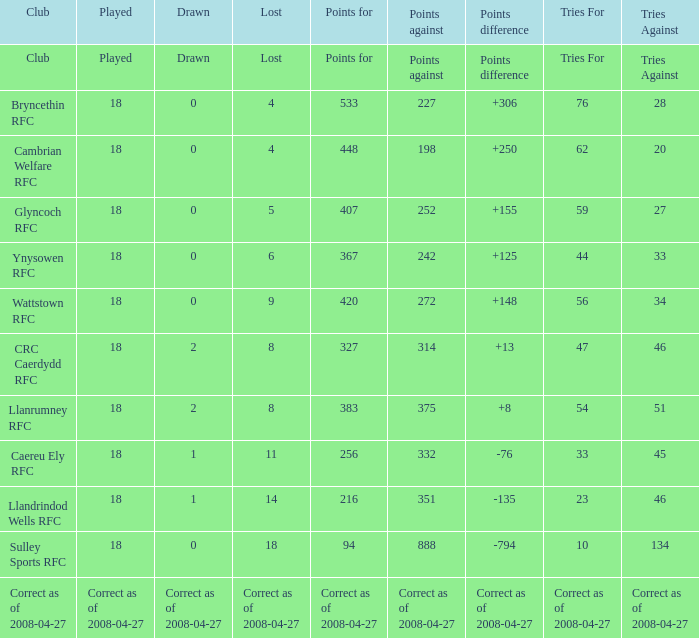What is the significance of the item "points" when the value of the item "points against" is 272? 420.0. Write the full table. {'header': ['Club', 'Played', 'Drawn', 'Lost', 'Points for', 'Points against', 'Points difference', 'Tries For', 'Tries Against'], 'rows': [['Club', 'Played', 'Drawn', 'Lost', 'Points for', 'Points against', 'Points difference', 'Tries For', 'Tries Against'], ['Bryncethin RFC', '18', '0', '4', '533', '227', '+306', '76', '28'], ['Cambrian Welfare RFC', '18', '0', '4', '448', '198', '+250', '62', '20'], ['Glyncoch RFC', '18', '0', '5', '407', '252', '+155', '59', '27'], ['Ynysowen RFC', '18', '0', '6', '367', '242', '+125', '44', '33'], ['Wattstown RFC', '18', '0', '9', '420', '272', '+148', '56', '34'], ['CRC Caerdydd RFC', '18', '2', '8', '327', '314', '+13', '47', '46'], ['Llanrumney RFC', '18', '2', '8', '383', '375', '+8', '54', '51'], ['Caereu Ely RFC', '18', '1', '11', '256', '332', '-76', '33', '45'], ['Llandrindod Wells RFC', '18', '1', '14', '216', '351', '-135', '23', '46'], ['Sulley Sports RFC', '18', '0', '18', '94', '888', '-794', '10', '134'], ['Correct as of 2008-04-27', 'Correct as of 2008-04-27', 'Correct as of 2008-04-27', 'Correct as of 2008-04-27', 'Correct as of 2008-04-27', 'Correct as of 2008-04-27', 'Correct as of 2008-04-27', 'Correct as of 2008-04-27', 'Correct as of 2008-04-27']]} 